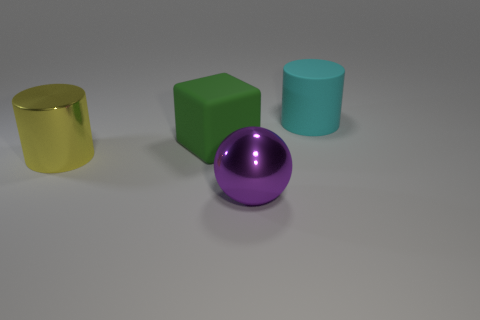Which object stands out the most due to its color, and why might that be? The shiny purple sphere stands out the most due to its vibrant color and reflective surface, which draws the eye more than the other objects. 